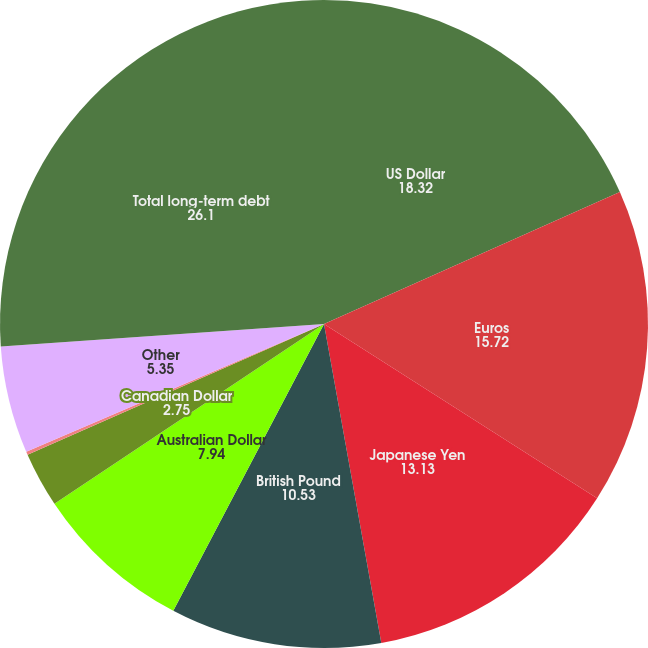<chart> <loc_0><loc_0><loc_500><loc_500><pie_chart><fcel>US Dollar<fcel>Euros<fcel>Japanese Yen<fcel>British Pound<fcel>Australian Dollar<fcel>Canadian Dollar<fcel>Swiss Franc<fcel>Other<fcel>Total long-term debt<nl><fcel>18.32%<fcel>15.72%<fcel>13.13%<fcel>10.53%<fcel>7.94%<fcel>2.75%<fcel>0.16%<fcel>5.35%<fcel>26.1%<nl></chart> 